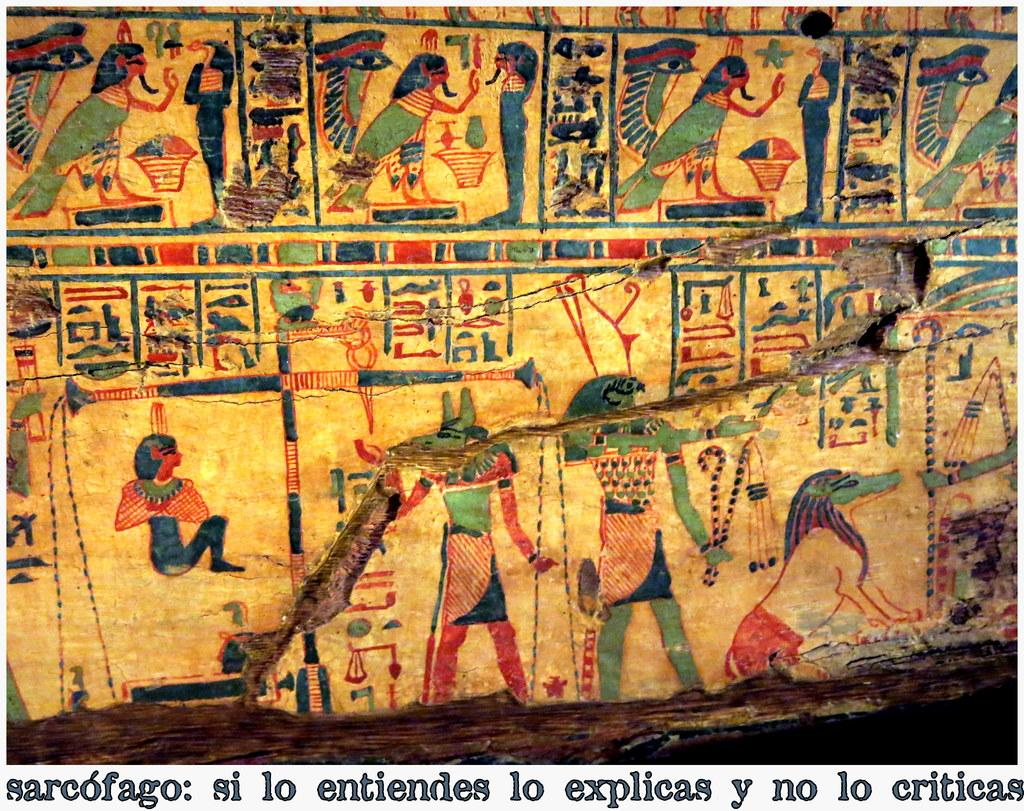What type of structure can be seen in the image? There is a wall in the image. How is the wall depicted? The wall appears to be truncated. Are there any visible defects on the wall? Yes, there are cracks on the wall. What is hanging on the wall? There is a painting on the wall. What additional information is provided at the bottom of the image? There is text at the bottom of the image. What type of beam is supporting the wall in the image? There is no beam visible in the image; it only shows a wall with cracks and a painting. How is the wax used in the image? There is no wax present in the image. 